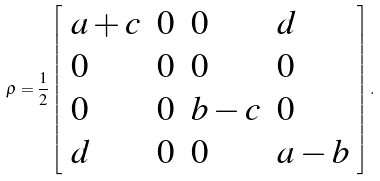<formula> <loc_0><loc_0><loc_500><loc_500>\rho = \frac { 1 } { 2 } \left [ \begin{array} { l l l l } a + c & 0 & 0 & d \\ 0 & 0 & 0 & 0 \\ 0 & 0 & b - c & 0 \\ d & 0 & 0 & a - b \end{array} \right ] .</formula> 